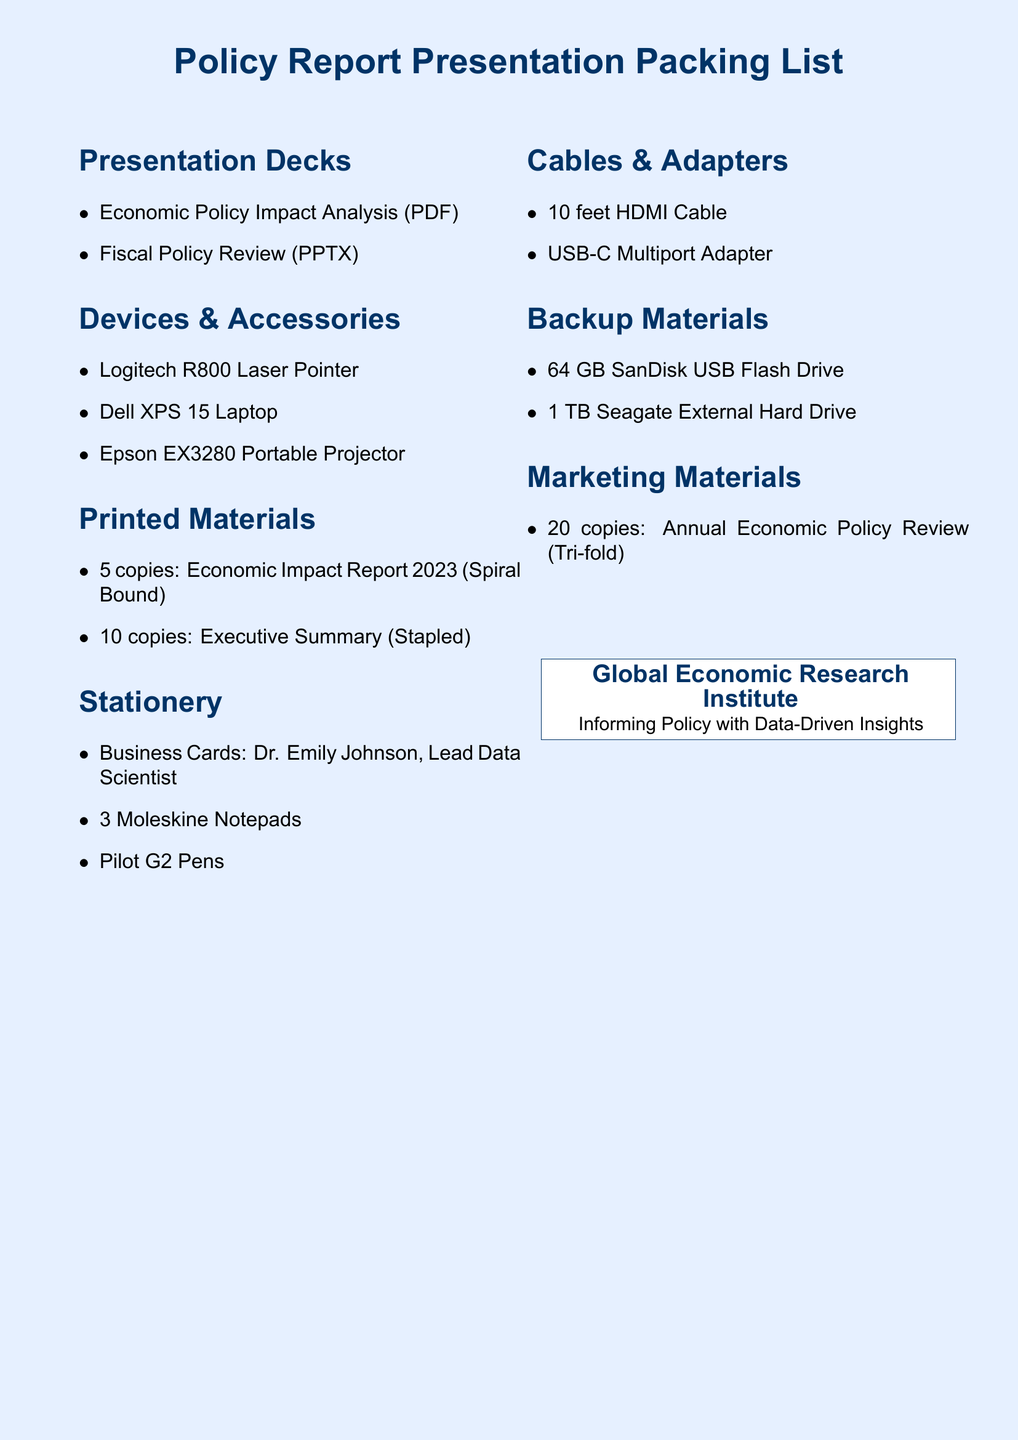What is the first item listed under Presentation Decks? The first item listed under Presentation Decks is the Economic Policy Impact Analysis.
Answer: Economic Policy Impact Analysis How many copies of the Economic Impact Report 2023 are prepared? The document states that there are 5 copies of the Economic Impact Report 2023 prepared.
Answer: 5 copies What type of projector is included in the Devices & Accessories section? The type of projector mentioned is the Epson EX3280 Portable Projector.
Answer: Epson EX3280 Portable Projector Which laser pointer is on the packing list? The laser pointer mentioned is the Logitech R800 Laser Pointer.
Answer: Logitech R800 Laser Pointer How many business cards are listed in the stationery section? The document mentions one set of business cards for Dr. Emily Johnson.
Answer: 1 set What storage capacity does the external hard drive have? The external hard drive has a capacity of 1 TB.
Answer: 1 TB What is the total number of printed copies included in the Packing List? The total number of printed copies includes 5 copies of Economic Impact Report 2023 and 10 copies of the Executive Summary, totaling 15 copies.
Answer: 15 copies What color is used for the page background? The color used for the page background is light blue.
Answer: Light blue Which section would you find the USB-C Multiport Adapter listed? The USB-C Multiport Adapter is listed under Cables & Adapters.
Answer: Cables & Adapters 